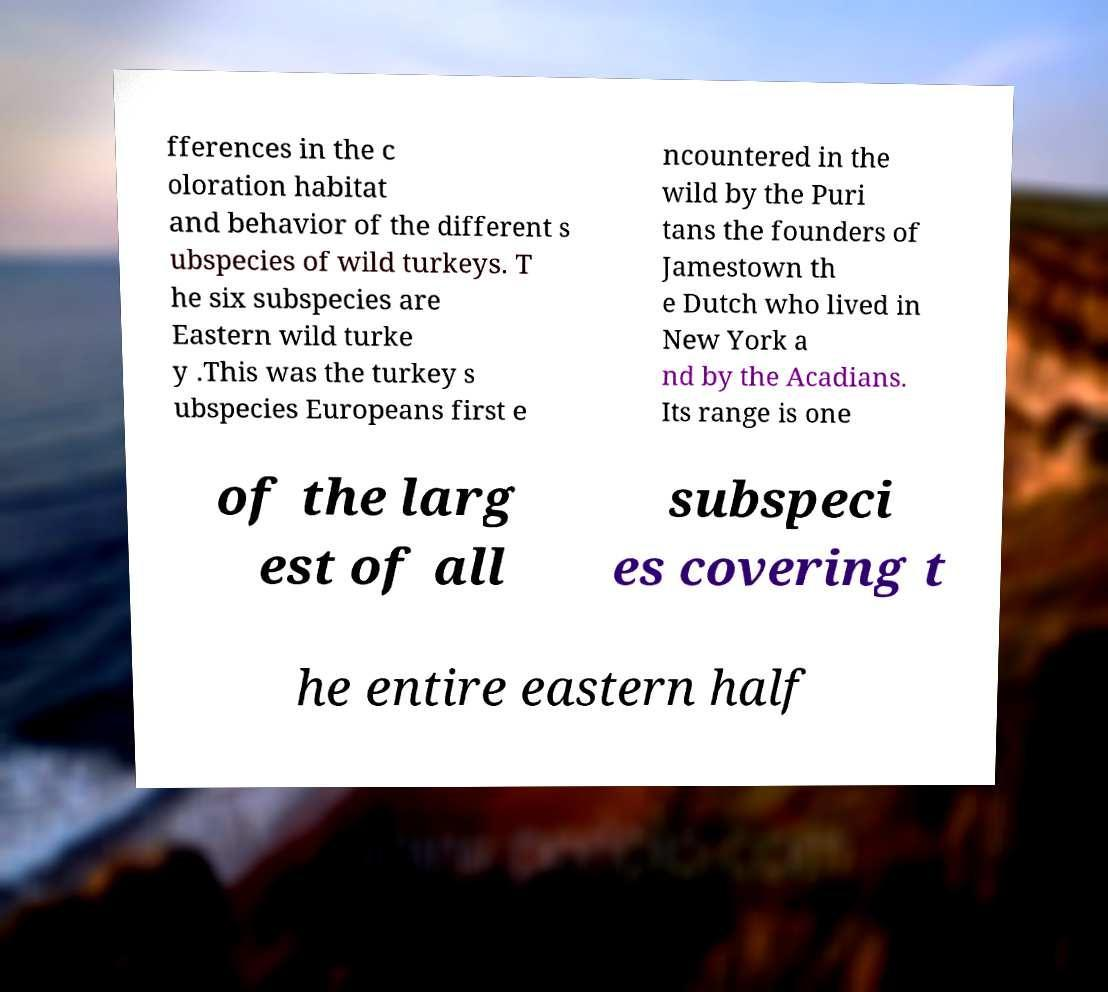For documentation purposes, I need the text within this image transcribed. Could you provide that? fferences in the c oloration habitat and behavior of the different s ubspecies of wild turkeys. T he six subspecies are Eastern wild turke y .This was the turkey s ubspecies Europeans first e ncountered in the wild by the Puri tans the founders of Jamestown th e Dutch who lived in New York a nd by the Acadians. Its range is one of the larg est of all subspeci es covering t he entire eastern half 